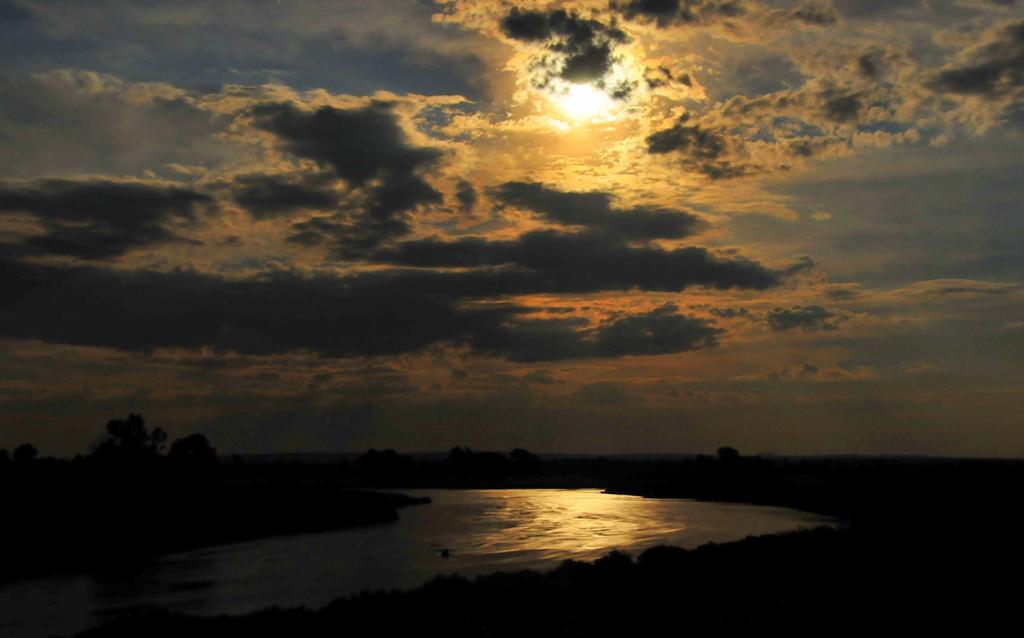Can you describe this image briefly? In this image there is water, trees, and in the background there is sky. 